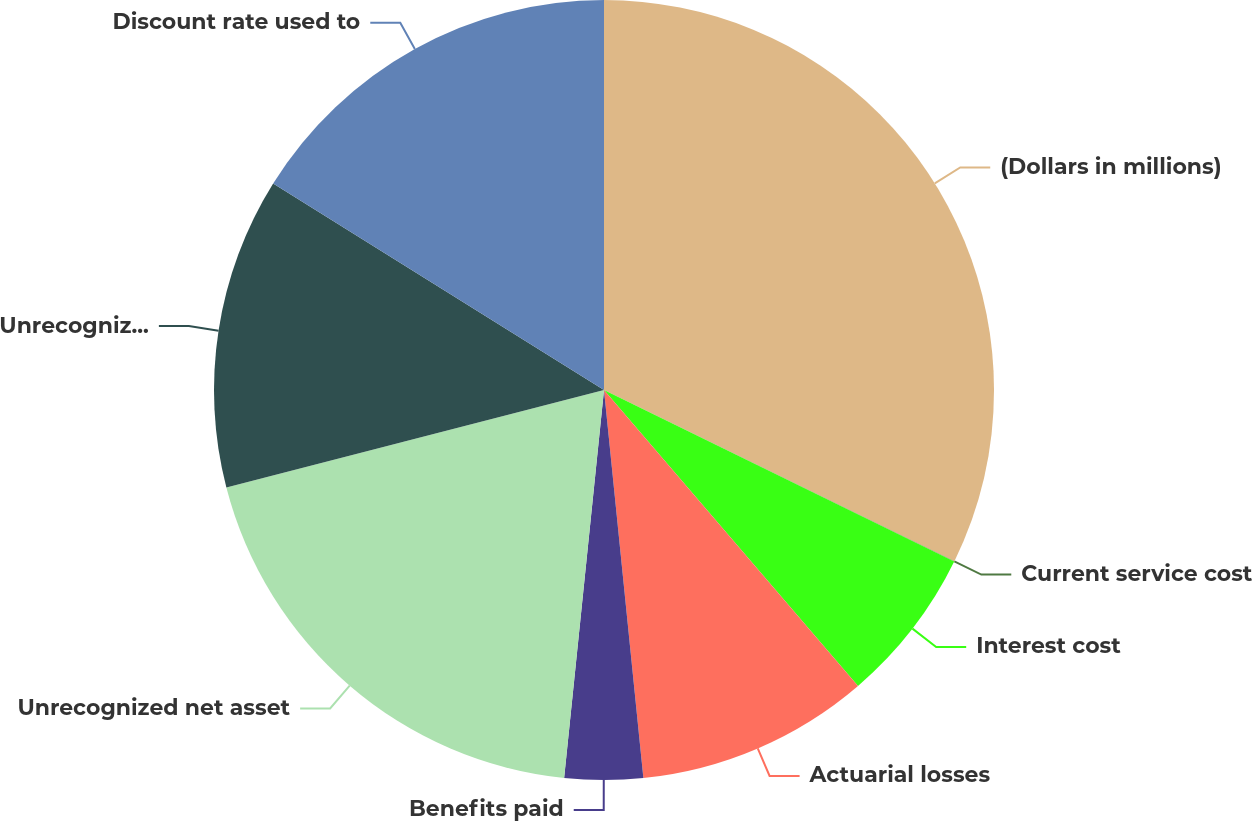Convert chart to OTSL. <chart><loc_0><loc_0><loc_500><loc_500><pie_chart><fcel>(Dollars in millions)<fcel>Current service cost<fcel>Interest cost<fcel>Actuarial losses<fcel>Benefits paid<fcel>Unrecognized net asset<fcel>Unrecognized net (losses)<fcel>Discount rate used to<nl><fcel>32.23%<fcel>0.02%<fcel>6.46%<fcel>9.68%<fcel>3.24%<fcel>19.35%<fcel>12.9%<fcel>16.12%<nl></chart> 